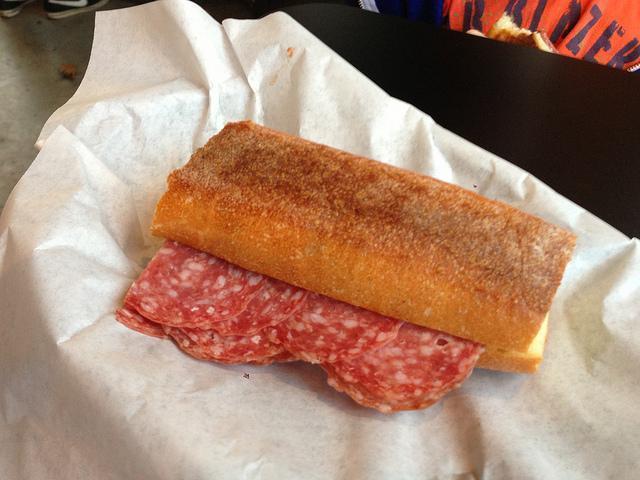How many pieces of bread are there?
Give a very brief answer. 2. 